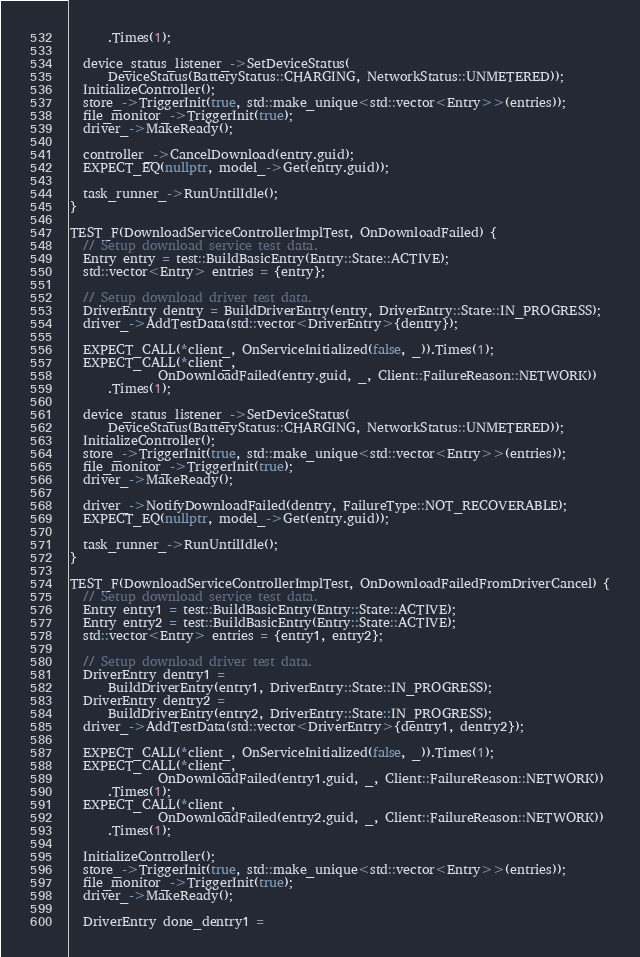Convert code to text. <code><loc_0><loc_0><loc_500><loc_500><_C++_>      .Times(1);

  device_status_listener_->SetDeviceStatus(
      DeviceStatus(BatteryStatus::CHARGING, NetworkStatus::UNMETERED));
  InitializeController();
  store_->TriggerInit(true, std::make_unique<std::vector<Entry>>(entries));
  file_monitor_->TriggerInit(true);
  driver_->MakeReady();

  controller_->CancelDownload(entry.guid);
  EXPECT_EQ(nullptr, model_->Get(entry.guid));

  task_runner_->RunUntilIdle();
}

TEST_F(DownloadServiceControllerImplTest, OnDownloadFailed) {
  // Setup download service test data.
  Entry entry = test::BuildBasicEntry(Entry::State::ACTIVE);
  std::vector<Entry> entries = {entry};

  // Setup download driver test data.
  DriverEntry dentry = BuildDriverEntry(entry, DriverEntry::State::IN_PROGRESS);
  driver_->AddTestData(std::vector<DriverEntry>{dentry});

  EXPECT_CALL(*client_, OnServiceInitialized(false, _)).Times(1);
  EXPECT_CALL(*client_,
              OnDownloadFailed(entry.guid, _, Client::FailureReason::NETWORK))
      .Times(1);

  device_status_listener_->SetDeviceStatus(
      DeviceStatus(BatteryStatus::CHARGING, NetworkStatus::UNMETERED));
  InitializeController();
  store_->TriggerInit(true, std::make_unique<std::vector<Entry>>(entries));
  file_monitor_->TriggerInit(true);
  driver_->MakeReady();

  driver_->NotifyDownloadFailed(dentry, FailureType::NOT_RECOVERABLE);
  EXPECT_EQ(nullptr, model_->Get(entry.guid));

  task_runner_->RunUntilIdle();
}

TEST_F(DownloadServiceControllerImplTest, OnDownloadFailedFromDriverCancel) {
  // Setup download service test data.
  Entry entry1 = test::BuildBasicEntry(Entry::State::ACTIVE);
  Entry entry2 = test::BuildBasicEntry(Entry::State::ACTIVE);
  std::vector<Entry> entries = {entry1, entry2};

  // Setup download driver test data.
  DriverEntry dentry1 =
      BuildDriverEntry(entry1, DriverEntry::State::IN_PROGRESS);
  DriverEntry dentry2 =
      BuildDriverEntry(entry2, DriverEntry::State::IN_PROGRESS);
  driver_->AddTestData(std::vector<DriverEntry>{dentry1, dentry2});

  EXPECT_CALL(*client_, OnServiceInitialized(false, _)).Times(1);
  EXPECT_CALL(*client_,
              OnDownloadFailed(entry1.guid, _, Client::FailureReason::NETWORK))
      .Times(1);
  EXPECT_CALL(*client_,
              OnDownloadFailed(entry2.guid, _, Client::FailureReason::NETWORK))
      .Times(1);

  InitializeController();
  store_->TriggerInit(true, std::make_unique<std::vector<Entry>>(entries));
  file_monitor_->TriggerInit(true);
  driver_->MakeReady();

  DriverEntry done_dentry1 =</code> 